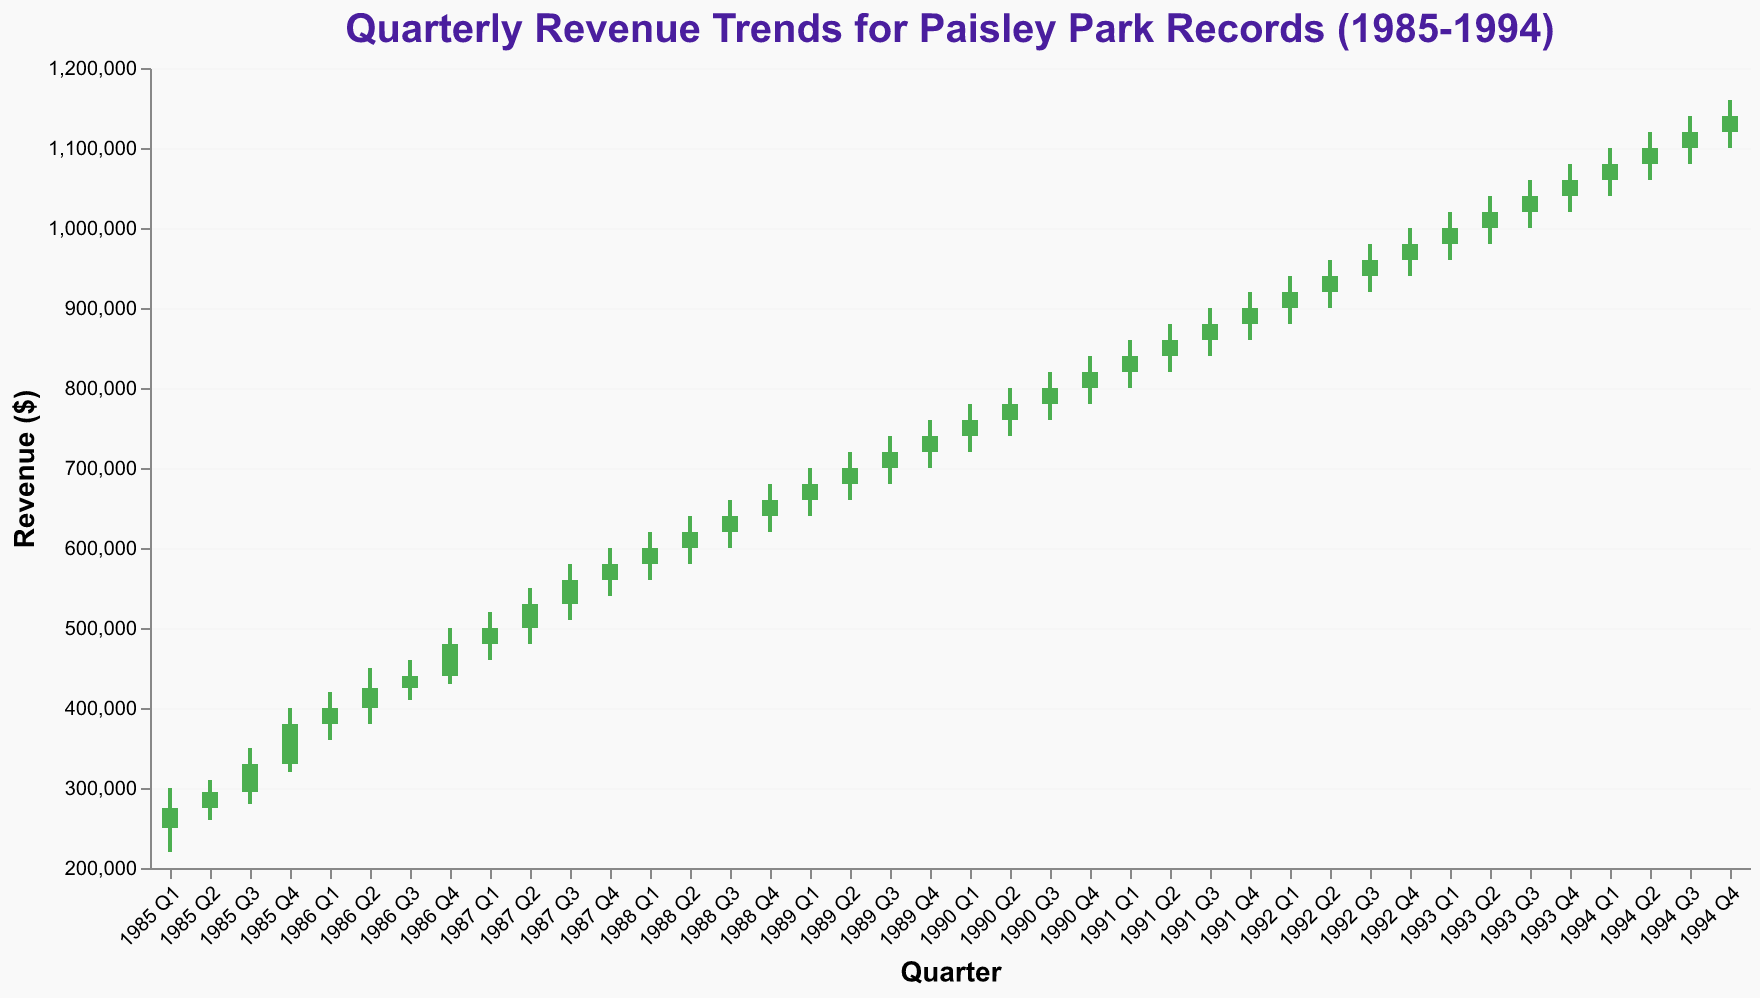What is the highest revenue recorded in any quarter? The highest revenue recorded in any quarter appears at the top of the bars representing the "High" value. The highest "High" value on the y-axis is 1,160,000 in 1994 Q4.
Answer: 1,160,000 What is the color representation for quarters where revenue increased? In the chart, quarters where the closing revenue is higher than the opening revenue are colored green.
Answer: Green In which quarter did Paisley Park Records first reach a revenue close value of $1,000,000? To find this, we look at the closing values on the y-axis. The quarter with the first $1,000,000 close is 1993 Q1.
Answer: 1993 Q1 What pattern can you observe about the revenue trends from 1985 Q1 to 1994 Q4? Examining the trend from left to right, the revenue shows a consistent increase over time, with both the highs and the lows steadily climbing higher each quarter. There's a continuous upward trend throughout the period.
Answer: Continuous upward trend Which quarter experienced the largest difference between the high and low values? To determine this, we need to find the quarter where the difference between the high and low values is greatest. The biggest difference is in 1985 Q4: (400,000 - 320,000) = 80,000.
Answer: 1985 Q4 Compare the revenue growth between 1988 Q4 and 1989 Q4. Was the increase steady or volatile? Comparing the two quarters, open, high, low, and close values from 1988 Q4 to 1989 Q4 show a steady increase from 640,000 to 720,000. The changes between the quarters appear smooth and incremental, indicating steady growth.
Answer: Steady growth What is the average revenue close value for the year 1987? To get the average close value for 1987: (500000 + 530000 + 560000 + 580000) / 4. Summing these, we get 2170000. Dividing by 4 gives us 542500.
Answer: 542500 How does the revenue trend in 1985 compare to the trend in 1994? In 1985, revenue shows a more volatile trend with significant fluctuations between quarters. In contrast, the trend in 1994 shows a more stabilized and consistently rising pattern, with each quarter slightly outperforming the previous.
Answer: More stable and consistently rising in 1994 Which years had all closing values above $900,000? Checking the closing values: 1992 (980,000, 1020000, 1040000, 1060000) and 1993 (1000000, 1020000, 1040000, 1060000) had all their closing values above $900,000.
Answer: 1993, 1994 